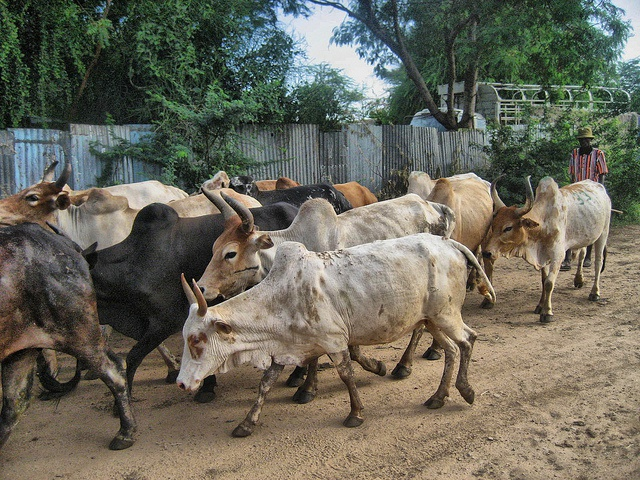Describe the objects in this image and their specific colors. I can see cow in olive, darkgray, and gray tones, cow in olive, black, and gray tones, cow in olive, black, and gray tones, cow in olive, darkgray, and gray tones, and cow in olive, darkgray, gray, and tan tones in this image. 